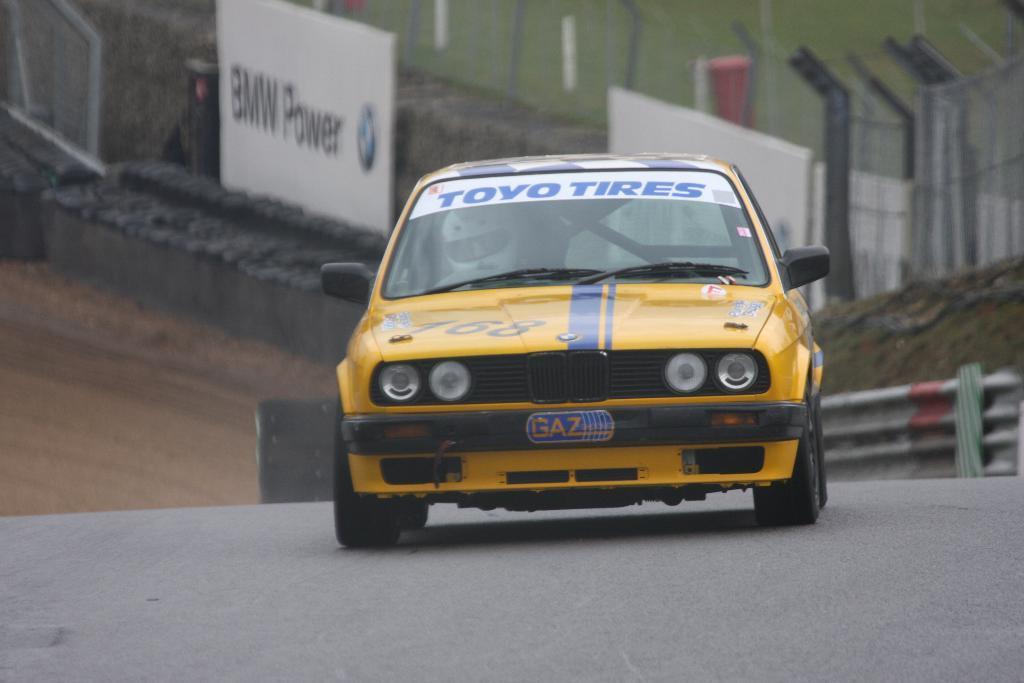Can you describe this image briefly? In this picture we can see a car on the road and in the background we can see banners, fences and some objects. 